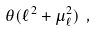<formula> <loc_0><loc_0><loc_500><loc_500>\theta ( \ell ^ { 2 } + \mu _ { \ell } ^ { 2 } ) \ ,</formula> 